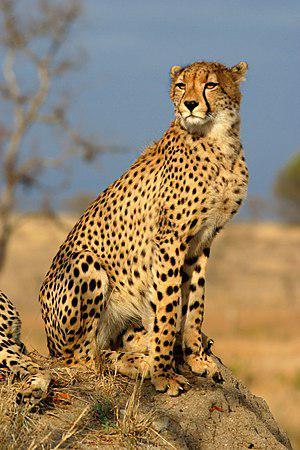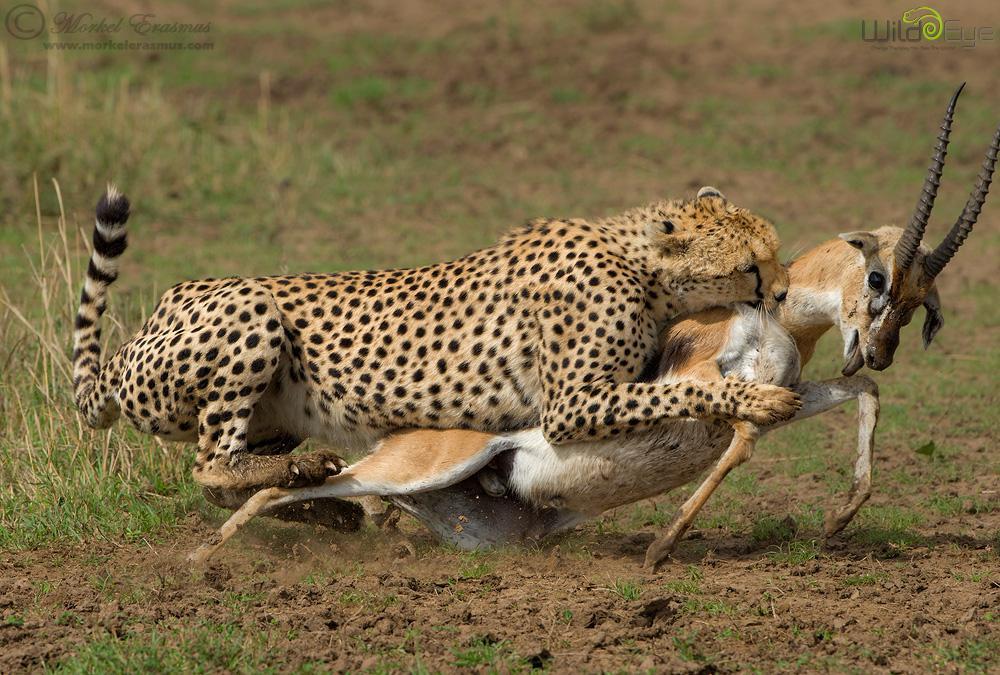The first image is the image on the left, the second image is the image on the right. Assess this claim about the two images: "One cheetah is capturing a gazelle in the right image, and the left image contains just one cheetah and no prey animal.". Correct or not? Answer yes or no. Yes. The first image is the image on the left, the second image is the image on the right. Considering the images on both sides, is "In one image there is a single cheetah and in the other there is a single cheetah successfully hunting an antelope." valid? Answer yes or no. Yes. 